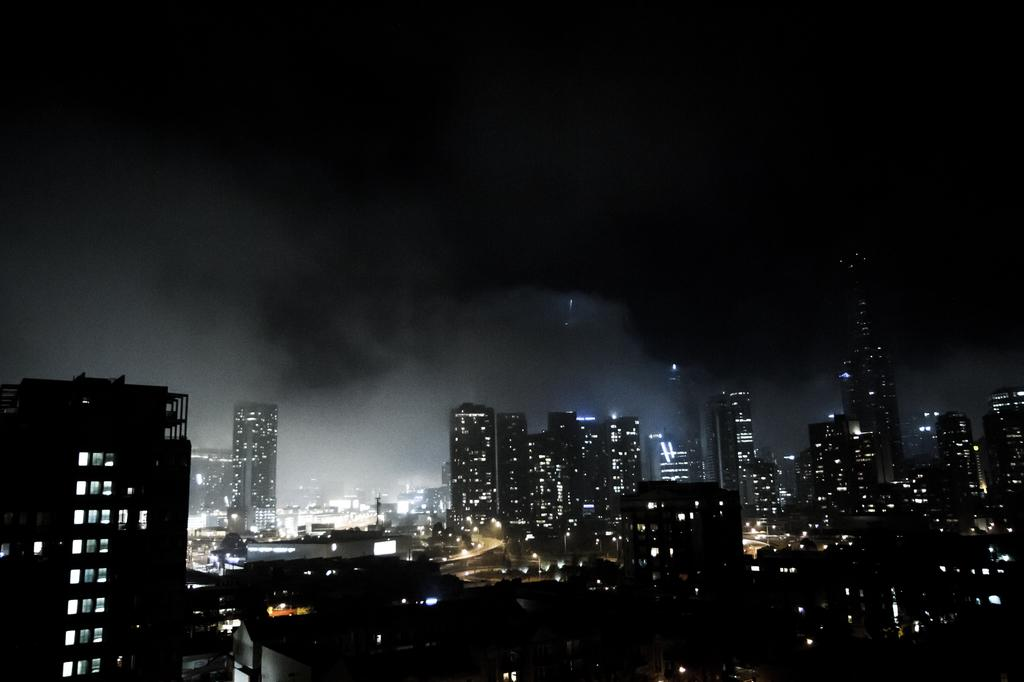What type of structures are present in the image? There is a group of buildings in the image. What can be seen illuminated in the image? There are lights visible in the image. What is visible in the background of the image? The sky is visible in the background of the image. What type of stamp can be seen on the vessel in the image? There is no vessel or stamp present in the image; it features a group of buildings and lights. Can you tell me how many chess pieces are visible on the table in the image? There is no table or chess pieces present in the image. 